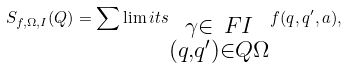Convert formula to latex. <formula><loc_0><loc_0><loc_500><loc_500>S _ { f , \Omega , I } ( Q ) = \sum \lim i t s _ { \substack { \gamma \in \ F I \\ ( q , q ^ { \prime } ) \in Q \Omega } } f ( q , q ^ { \prime } , a ) ,</formula> 